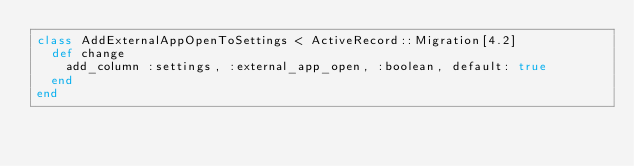Convert code to text. <code><loc_0><loc_0><loc_500><loc_500><_Ruby_>class AddExternalAppOpenToSettings < ActiveRecord::Migration[4.2]
  def change
    add_column :settings, :external_app_open, :boolean, default: true
  end
end
</code> 